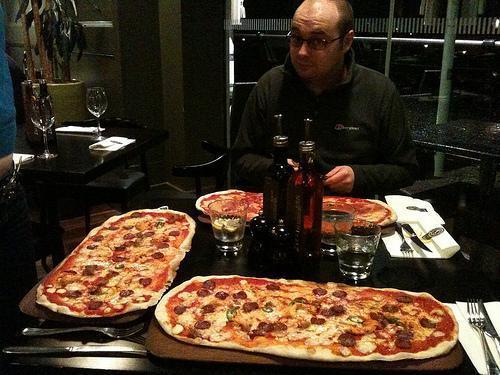How many tables are in the picture?
Give a very brief answer. 2. How many liquor bottle?
Give a very brief answer. 2. How many pizzas?
Give a very brief answer. 3. How many people are pictured?
Give a very brief answer. 1. 